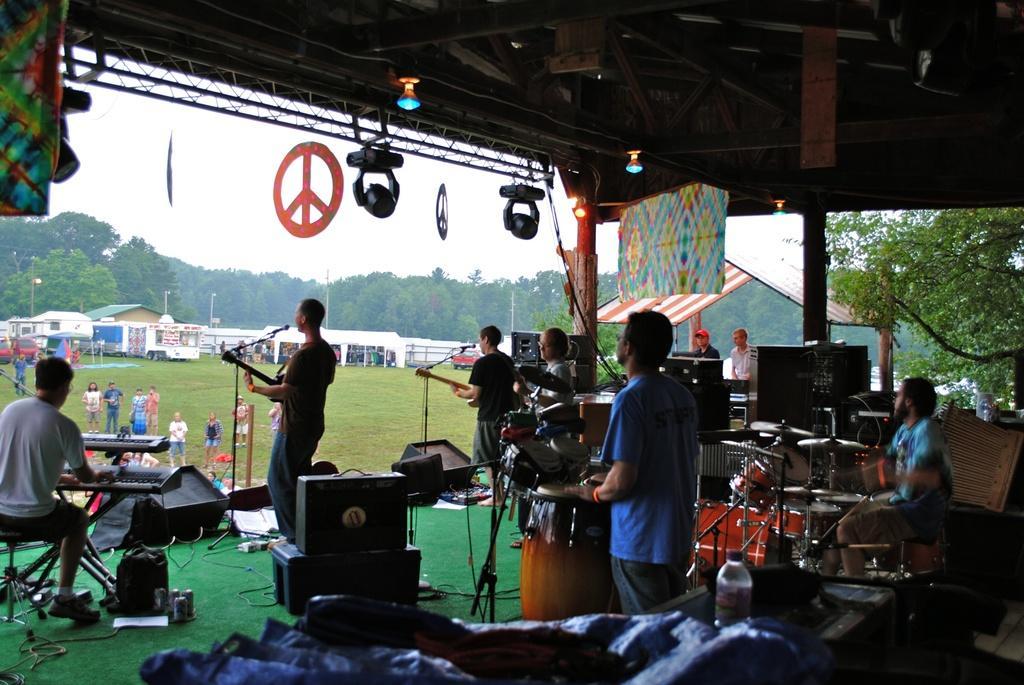Please provide a concise description of this image. There are group people here on the stage performing by playing musical instruments. In front of them there are buildings,vehicles,children and people,trees,sky. 